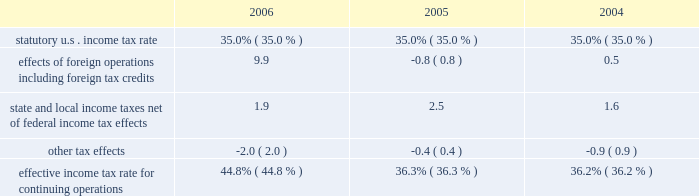For additional information on segment results see page 43 .
Income from equity method investments increased by $ 126 million in 2006 from 2005 and increased by $ 98 million in 2005 from 2004 .
Income from our lpg operations in equatorial guinea increased in both periods due to higher sales volumes as a result of the plant expansions completed in 2005 .
The increase in 2005 also included higher ptc income as a result of higher distillate gross margins .
Cost of revenues increased $ 4.609 billion in 2006 from 2005 and $ 7.106 billion in 2005 from 2004 .
In both periods the increases were primarily in the rm&t segment and resulted from increases in acquisition costs of crude oil , refinery charge and blend stocks and purchased refined products .
The increase in both periods was also impacted by higher manufacturing expenses , primarily the result of higher contract services and labor costs in 2006 and higher purchased energy costs in 2005 .
Purchases related to matching buy/sell transactions decreased $ 6.968 billion in 2006 from 2005 and increased $ 3.314 billion in 2005 from 2004 , mostly in the rm&t segment .
The decrease in 2006 was primarily related to the change in accounting for matching buy/sell transactions discussed above .
The increase in 2005 was primarily due to increased crude oil prices .
Depreciation , depletion and amortization increased $ 215 million in 2006 from 2005 and $ 125 million in 2005 from 2004 .
Rm&t segment depreciation expense increased in both years as a result of the increase in asset value recorded for our acquisition of the 38 percent interest in mpc on june 30 , 2005 .
In addition , the detroit refinery expansion completed in the fourth quarter of 2005 contributed to the rm&t depreciation expense increase in 2006 .
E&p segment depreciation expense for 2006 included a $ 20 million impairment of capitalized costs related to the camden hills field in the gulf of mexico and the associated canyon express pipeline .
Natural gas production from the camden hills field ended in 2006 as a result of increased water production from the well .
Selling , general and administrative expenses increased $ 73 million in 2006 from 2005 and $ 134 million in 2005 from 2004 .
The 2006 increase was primarily because personnel and staffing costs increased throughout the year primarily as a result of variable compensation arrangements and increased business activity .
Partially offsetting these increases were reductions in stock-based compensation expense .
The increase in 2005 was primarily a result of increased stock-based compensation expense , due to the increase in our stock price during that year as well as an increase in equity-based awards , which was partially offset by a decrease in expense as a result of severance and pension plan curtailment charges and start-up costs related to egholdings in 2004 .
Exploration expenses increased $ 148 million in 2006 from 2005 and $ 59 million in 2005 from 2004 .
Exploration expense related to dry wells and other write-offs totaled $ 166 million , $ 111 million and $ 47 million in 2006 , 2005 and 2004 .
Exploration expense in 2006 also included $ 47 million for exiting the cortland and empire leases in nova scotia .
Net interest and other financing costs ( income ) reflected a net $ 37 million of income for 2006 , a favorable change of $ 183 million from the net $ 146 million expense in 2005 .
Net interest and other financing costs decreased $ 16 million in 2005 from 2004 .
The favorable changes in 2006 included increased interest income due to higher interest rates and average cash balances , foreign currency exchange gains , adjustments to interest on tax issues and greater capitalized interest .
The decrease in expense for 2005 was primarily a result of increased interest income on higher average cash balances and greater capitalized interest , partially offset by increased interest on potential tax deficiencies and higher foreign exchange losses .
Included in net interest and other financing costs ( income ) are foreign currency gains of $ 16 million , losses of $ 17 million and gains of $ 9 million for 2006 , 2005 and 2004 .
Minority interest in income of mpc decreased $ 148 million in 2005 from 2004 due to our acquisition of the 38 percent interest in mpc on june 30 , 2005 .
Provision for income taxes increased $ 2.308 billion in 2006 from 2005 and $ 979 million in 2005 from 2004 , primarily due to the $ 4.259 billion and $ 2.691 billion increases in income from continuing operations before income taxes .
The increase in our effective income tax rate in 2006 was primarily a result of the income taxes related to our libyan operations , where the statutory income tax rate is in excess of 90 percent .
The following is an analysis of the effective income tax rates for continuing operations for 2006 , 2005 and 2004 .
See note 11 to the consolidated financial statements for further discussion. .

By how much did the effective income tax rate for continuing operations increase from 2005 to 2006? 
Computations: (44.8% - 36.3%)
Answer: 0.085. 